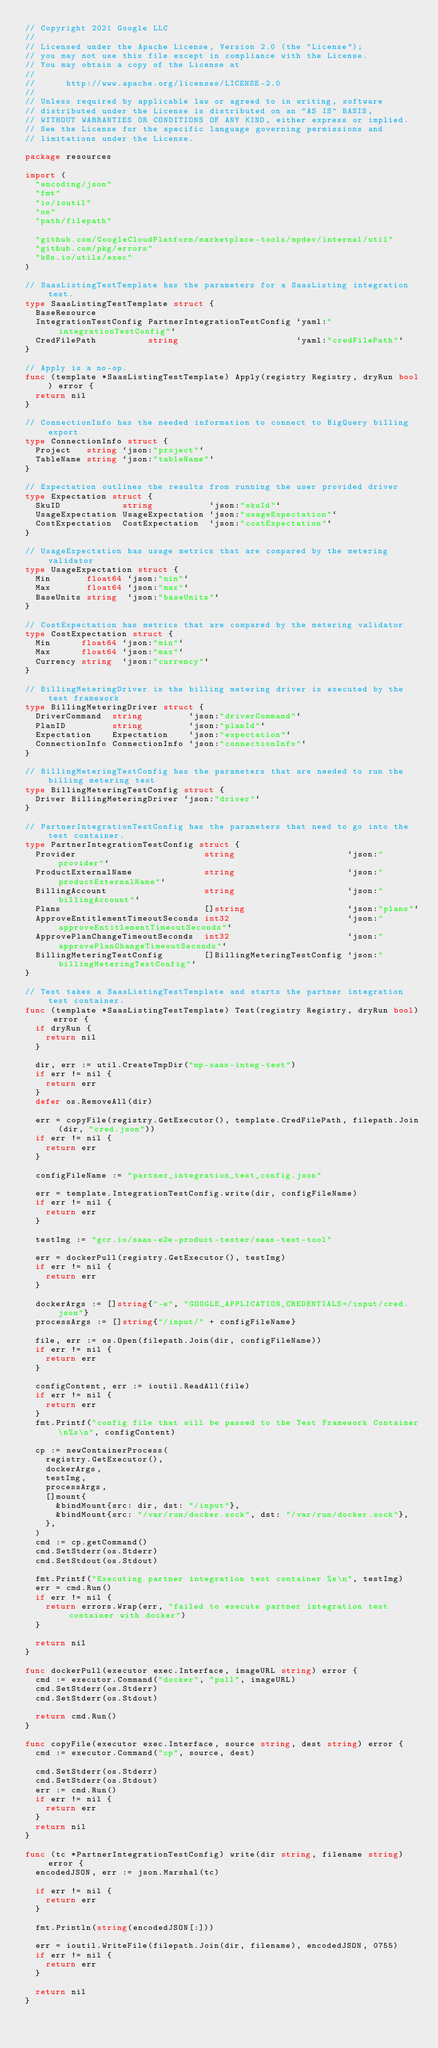<code> <loc_0><loc_0><loc_500><loc_500><_Go_>// Copyright 2021 Google LLC
//
// Licensed under the Apache License, Version 2.0 (the "License");
// you may not use this file except in compliance with the License.
// You may obtain a copy of the License at
//
//      http://www.apache.org/licenses/LICENSE-2.0
//
// Unless required by applicable law or agreed to in writing, software
// distributed under the License is distributed on an "AS IS" BASIS,
// WITHOUT WARRANTIES OR CONDITIONS OF ANY KIND, either express or implied.
// See the License for the specific language governing permissions and
// limitations under the License.

package resources

import (
	"encoding/json"
	"fmt"
	"io/ioutil"
	"os"
	"path/filepath"

	"github.com/GoogleCloudPlatform/marketplace-tools/mpdev/internal/util"
	"github.com/pkg/errors"
	"k8s.io/utils/exec"
)

// SaasListingTestTemplate has the parameters for a SaasListing integration test.
type SaasListingTestTemplate struct {
	BaseResource
	IntegrationTestConfig PartnerIntegrationTestConfig `yaml:"integrationTestConfig"`
	CredFilePath          string                       `yaml:"credFilePath"`
}

// Apply is a no-op.
func (template *SaasListingTestTemplate) Apply(registry Registry, dryRun bool) error {
	return nil
}

// ConnectionInfo has the needed information to connect to BigQuery billing export
type ConnectionInfo struct {
	Project   string `json:"project"`
	TableName string `json:"tableName"`
}

// Expectation outlines the results from running the user provided driver
type Expectation struct {
	SkuID            string           `json:"skuId"`
	UsageExpectation UsageExpectation `json:"usageExpectation"`
	CostExpectation  CostExpectation  `json:"costExpectation"`
}

// UsageExpectation has usage metrics that are compared by the metering validator
type UsageExpectation struct {
	Min       float64 `json:"min"`
	Max       float64 `json:"max"`
	BaseUnits string  `json:"baseUnits"`
}

// CostExpectation has metrics that are compared by the metering validator
type CostExpectation struct {
	Min      float64 `json:"min"`
	Max      float64 `json:"max"`
	Currency string  `json:"currency"`
}

// BillingMeteringDriver is the billing metering driver is executed by the test framework
type BillingMeteringDriver struct {
	DriverCommand  string         `json:"driverCommand"`
	PlanID         string         `json:"planId"`
	Expectation    Expectation    `json:"expectation"`
	ConnectionInfo ConnectionInfo `json:"connectionInfo"`
}

// BillingMeteringTestConfig has the parameters that are needed to run the billing metering test
type BillingMeteringTestConfig struct {
	Driver BillingMeteringDriver `json:"driver"`
}

// PartnerIntegrationTestConfig has the parameters that need to go into the test container.
type PartnerIntegrationTestConfig struct {
	Provider                         string                      `json:"provider"`
	ProductExternalName              string                      `json:"productExternalName"`
	BillingAccount                   string                      `json:"billingAccount"`
	Plans                            []string                    `json:"plans"`
	ApproveEntitlementTimeoutSeconds int32                       `json:"approveEntitlementTimeoutSeconds"`
	ApprovePlanChangeTimeoutSeconds  int32                       `json:"approvePlanChangeTimeoutSeconds"`
	BillingMeteringTestConfig        []BillingMeteringTestConfig `json:"billingMeteringTestConfig"`
}

// Test takes a SaasListingTestTemplate and starts the partner integration test container.
func (template *SaasListingTestTemplate) Test(registry Registry, dryRun bool) error {
	if dryRun {
		return nil
	}

	dir, err := util.CreateTmpDir("mp-saas-integ-test")
	if err != nil {
		return err
	}
	defer os.RemoveAll(dir)

	err = copyFile(registry.GetExecutor(), template.CredFilePath, filepath.Join(dir, "cred.json"))
	if err != nil {
		return err
	}

	configFileName := "partner_integration_test_config.json"

	err = template.IntegrationTestConfig.write(dir, configFileName)
	if err != nil {
		return err
	}

	testImg := "gcr.io/saas-e2e-product-tester/saas-test-tool"

	err = dockerPull(registry.GetExecutor(), testImg)
	if err != nil {
		return err
	}

	dockerArgs := []string{"-e", "GOOGLE_APPLICATION_CREDENTIALS=/input/cred.json"}
	processArgs := []string{"/input/" + configFileName}

	file, err := os.Open(filepath.Join(dir, configFileName))
	if err != nil {
		return err
	}

	configContent, err := ioutil.ReadAll(file)
	if err != nil {
		return err
	}
	fmt.Printf("config file that will be passed to the Test Framework Container\n%s\n", configContent)

	cp := newContainerProcess(
		registry.GetExecutor(),
		dockerArgs,
		testImg,
		processArgs,
		[]mount{
			&bindMount{src: dir, dst: "/input"},
			&bindMount{src: "/var/run/docker.sock", dst: "/var/run/docker.sock"},
		},
	)
	cmd := cp.getCommand()
	cmd.SetStderr(os.Stderr)
	cmd.SetStdout(os.Stdout)

	fmt.Printf("Executing partner integration test container %s\n", testImg)
	err = cmd.Run()
	if err != nil {
		return errors.Wrap(err, "failed to execute partner integration test container with docker")
	}

	return nil
}

func dockerPull(executor exec.Interface, imageURL string) error {
	cmd := executor.Command("docker", "pull", imageURL)
	cmd.SetStderr(os.Stderr)
	cmd.SetStderr(os.Stdout)

	return cmd.Run()
}

func copyFile(executor exec.Interface, source string, dest string) error {
	cmd := executor.Command("cp", source, dest)

	cmd.SetStderr(os.Stderr)
	cmd.SetStderr(os.Stdout)
	err := cmd.Run()
	if err != nil {
		return err
	}
	return nil
}

func (tc *PartnerIntegrationTestConfig) write(dir string, filename string) error {
	encodedJSON, err := json.Marshal(tc)

	if err != nil {
		return err
	}

	fmt.Println(string(encodedJSON[:]))

	err = ioutil.WriteFile(filepath.Join(dir, filename), encodedJSON, 0755)
	if err != nil {
		return err
	}

	return nil
}
</code> 